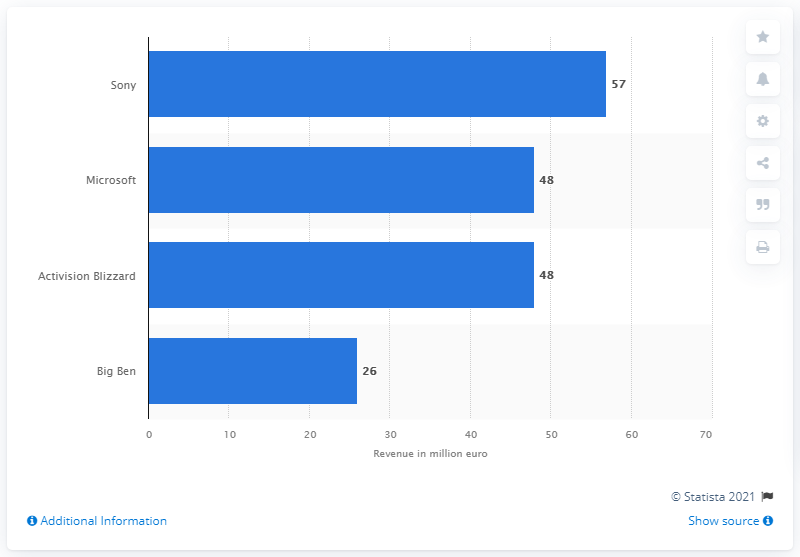Indicate a few pertinent items in this graphic. In 2013, Sony reported sales revenue of 57 billion US dollars. In 2013, Sony was the leading video game accessory retailer in France. 